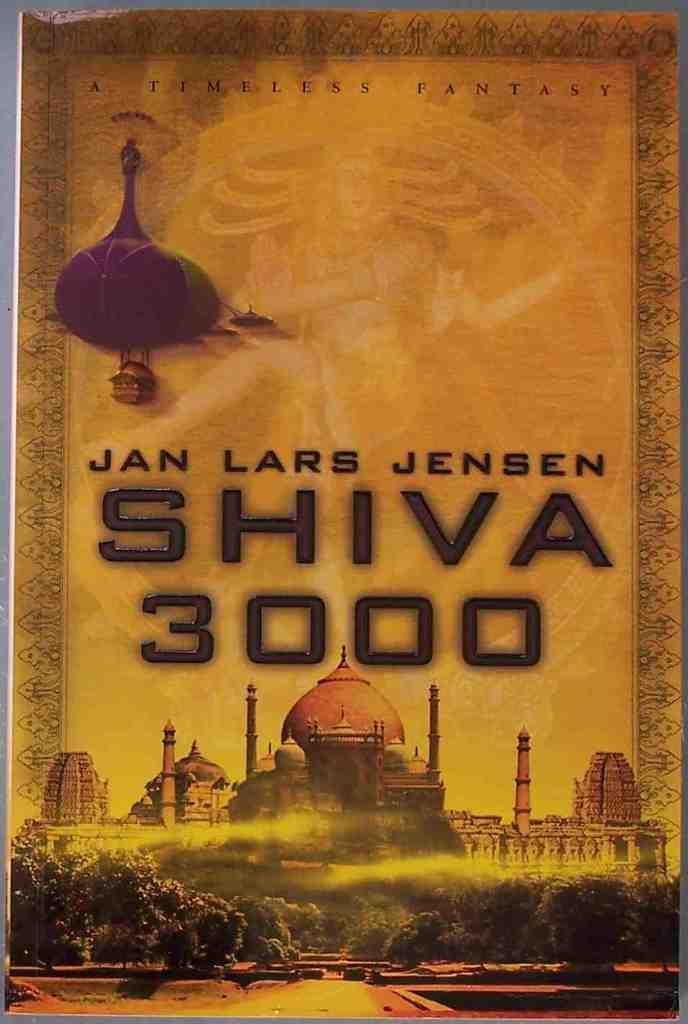Describe this image in one or two sentences. This is a picture of a poster. We can see the depictions and some information. 